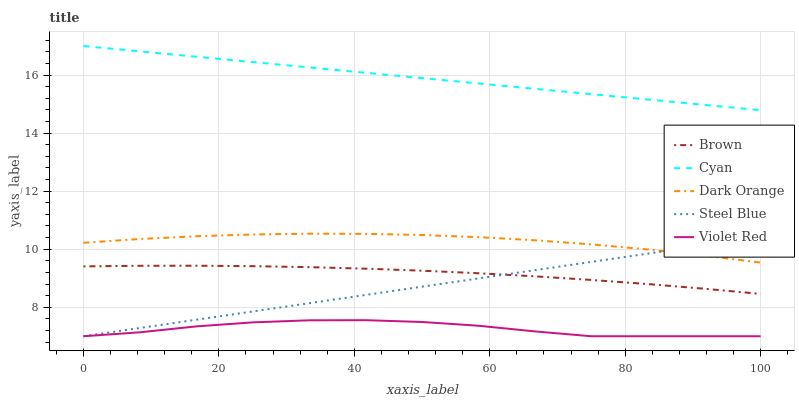Does Violet Red have the minimum area under the curve?
Answer yes or no. Yes. Does Cyan have the maximum area under the curve?
Answer yes or no. Yes. Does Brown have the minimum area under the curve?
Answer yes or no. No. Does Brown have the maximum area under the curve?
Answer yes or no. No. Is Steel Blue the smoothest?
Answer yes or no. Yes. Is Violet Red the roughest?
Answer yes or no. Yes. Is Brown the smoothest?
Answer yes or no. No. Is Brown the roughest?
Answer yes or no. No. Does Violet Red have the lowest value?
Answer yes or no. Yes. Does Brown have the lowest value?
Answer yes or no. No. Does Cyan have the highest value?
Answer yes or no. Yes. Does Brown have the highest value?
Answer yes or no. No. Is Dark Orange less than Cyan?
Answer yes or no. Yes. Is Brown greater than Violet Red?
Answer yes or no. Yes. Does Steel Blue intersect Violet Red?
Answer yes or no. Yes. Is Steel Blue less than Violet Red?
Answer yes or no. No. Is Steel Blue greater than Violet Red?
Answer yes or no. No. Does Dark Orange intersect Cyan?
Answer yes or no. No. 